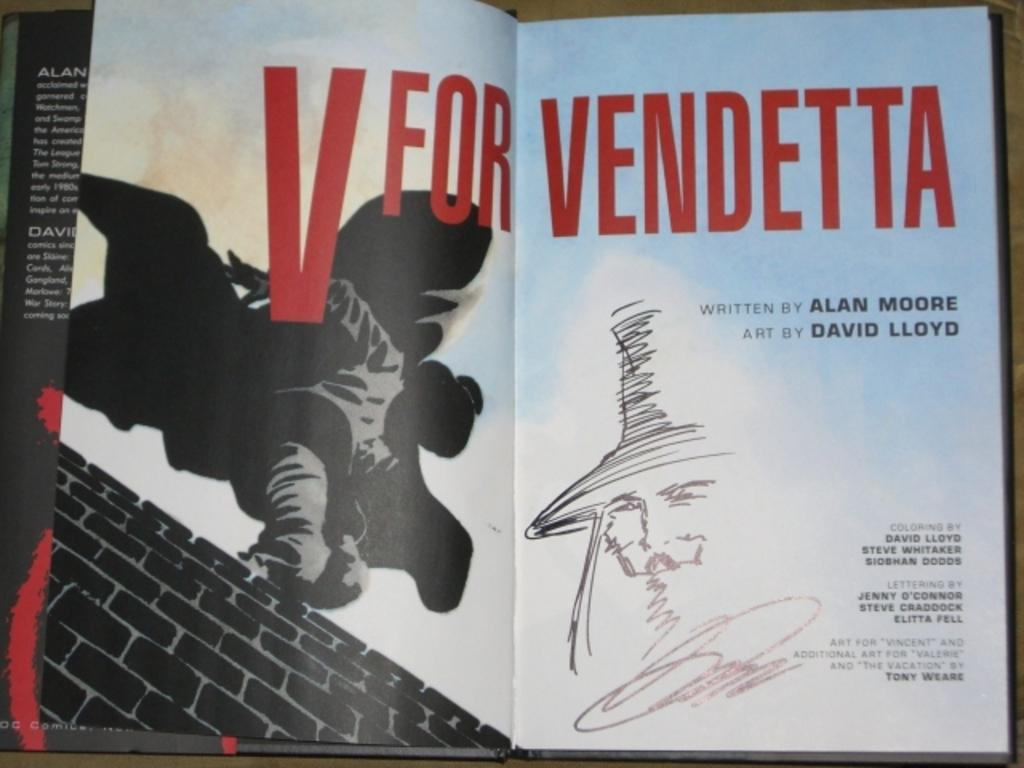<image>
Describe the image concisely. Jenny O'Conner worded on the lettering, along with 2 others. 